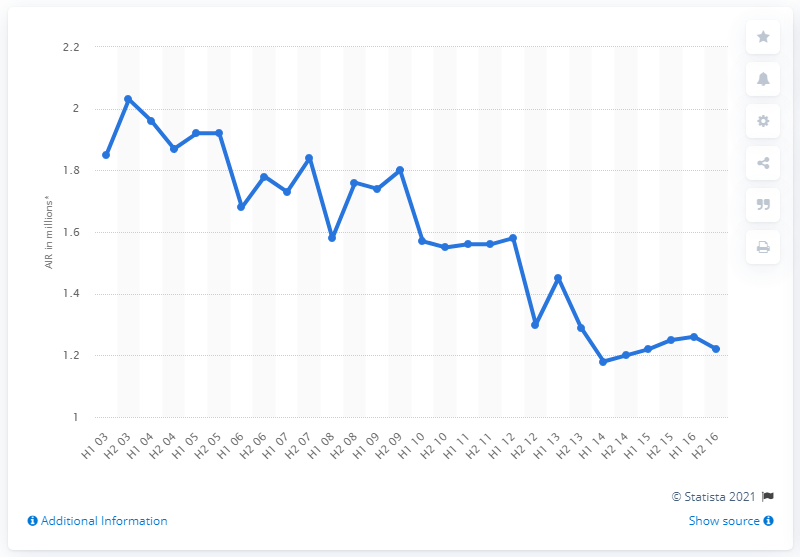Point out several critical features in this image. In the second half of 2015, the average number of readers per issue of Cosmopolitan magazine was 1.29. 